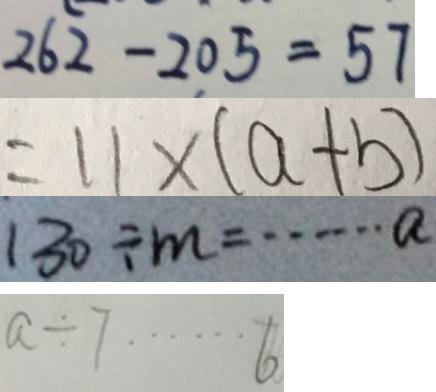<formula> <loc_0><loc_0><loc_500><loc_500>2 6 2 - 2 0 5 = 5 7 
 = 1 1 \times ( a + b ) 
 1 3 0 \div m = \cdots a 
 a \div 7 \cdots 6</formula> 